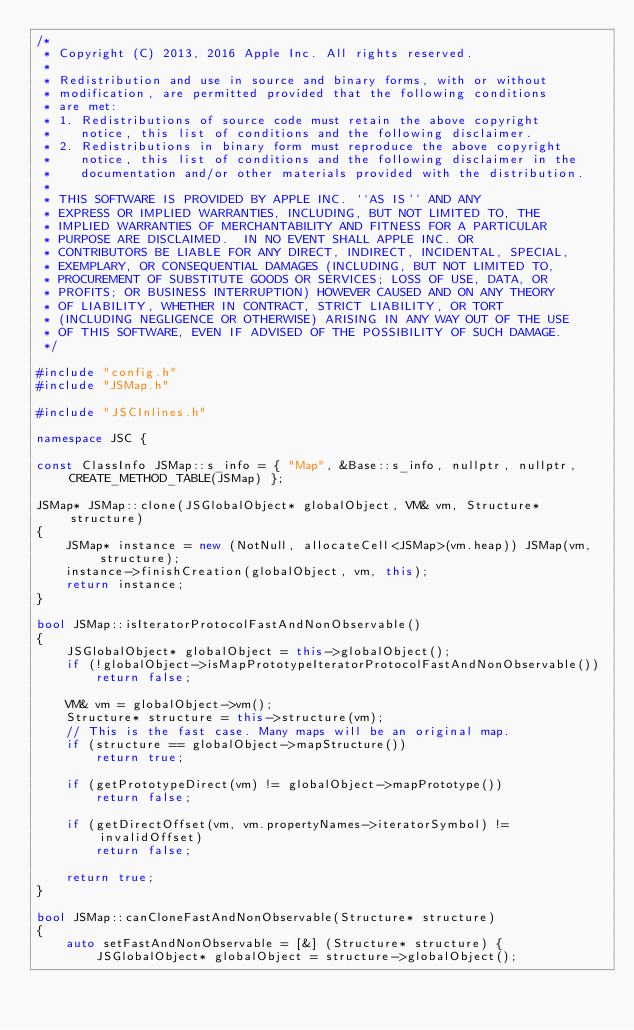Convert code to text. <code><loc_0><loc_0><loc_500><loc_500><_C++_>/*
 * Copyright (C) 2013, 2016 Apple Inc. All rights reserved.
 *
 * Redistribution and use in source and binary forms, with or without
 * modification, are permitted provided that the following conditions
 * are met:
 * 1. Redistributions of source code must retain the above copyright
 *    notice, this list of conditions and the following disclaimer.
 * 2. Redistributions in binary form must reproduce the above copyright
 *    notice, this list of conditions and the following disclaimer in the
 *    documentation and/or other materials provided with the distribution.
 *
 * THIS SOFTWARE IS PROVIDED BY APPLE INC. ``AS IS'' AND ANY
 * EXPRESS OR IMPLIED WARRANTIES, INCLUDING, BUT NOT LIMITED TO, THE
 * IMPLIED WARRANTIES OF MERCHANTABILITY AND FITNESS FOR A PARTICULAR
 * PURPOSE ARE DISCLAIMED.  IN NO EVENT SHALL APPLE INC. OR
 * CONTRIBUTORS BE LIABLE FOR ANY DIRECT, INDIRECT, INCIDENTAL, SPECIAL,
 * EXEMPLARY, OR CONSEQUENTIAL DAMAGES (INCLUDING, BUT NOT LIMITED TO,
 * PROCUREMENT OF SUBSTITUTE GOODS OR SERVICES; LOSS OF USE, DATA, OR
 * PROFITS; OR BUSINESS INTERRUPTION) HOWEVER CAUSED AND ON ANY THEORY
 * OF LIABILITY, WHETHER IN CONTRACT, STRICT LIABILITY, OR TORT
 * (INCLUDING NEGLIGENCE OR OTHERWISE) ARISING IN ANY WAY OUT OF THE USE
 * OF THIS SOFTWARE, EVEN IF ADVISED OF THE POSSIBILITY OF SUCH DAMAGE.
 */

#include "config.h"
#include "JSMap.h"

#include "JSCInlines.h"

namespace JSC {

const ClassInfo JSMap::s_info = { "Map", &Base::s_info, nullptr, nullptr, CREATE_METHOD_TABLE(JSMap) };

JSMap* JSMap::clone(JSGlobalObject* globalObject, VM& vm, Structure* structure)
{
    JSMap* instance = new (NotNull, allocateCell<JSMap>(vm.heap)) JSMap(vm, structure);
    instance->finishCreation(globalObject, vm, this);
    return instance;
}

bool JSMap::isIteratorProtocolFastAndNonObservable()
{
    JSGlobalObject* globalObject = this->globalObject();
    if (!globalObject->isMapPrototypeIteratorProtocolFastAndNonObservable())
        return false;

    VM& vm = globalObject->vm();
    Structure* structure = this->structure(vm);
    // This is the fast case. Many maps will be an original map.
    if (structure == globalObject->mapStructure())
        return true;

    if (getPrototypeDirect(vm) != globalObject->mapPrototype())
        return false;

    if (getDirectOffset(vm, vm.propertyNames->iteratorSymbol) != invalidOffset)
        return false;

    return true;
}

bool JSMap::canCloneFastAndNonObservable(Structure* structure)
{
    auto setFastAndNonObservable = [&] (Structure* structure) {
        JSGlobalObject* globalObject = structure->globalObject();</code> 